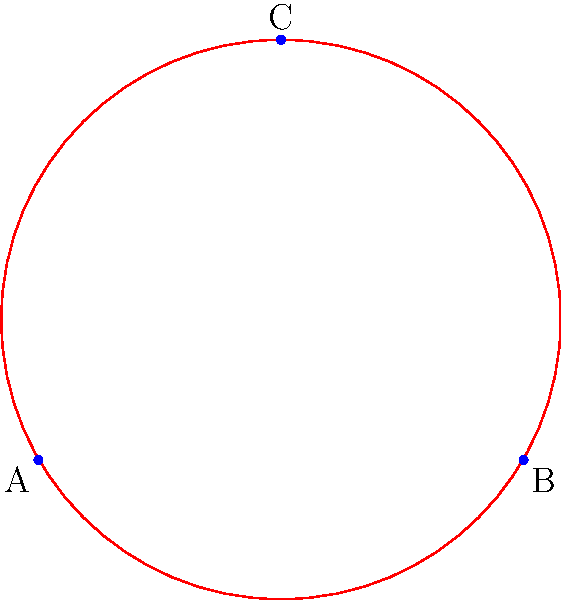A hungry wolf spots three sheep grazing in a field, represented by points A, B, and C. The wolf wants to encircle all three sheep with the smallest possible circular fence. If the distance between sheep A and B is 3 units, what is the radius of the smallest circle that can enclose all three sheep? To find the radius of the smallest circle enclosing three points, we need to follow these steps:

1) First, we recognize that the smallest circle enclosing three points is either:
   a) The circumcircle of the triangle formed by the three points, or
   b) The circle with two of the points as a diameter (if the triangle is obtuse).

2) In this case, we're given that the distance between A and B is 3 units. Let's assume A is at (0,0) and B is at (3,0).

3) To determine the position of C, we can use the properties of an equilateral triangle. The height of an equilateral triangle with side length 3 is $3\sqrt{3}/2 \approx 2.6$ units.

4) So, the coordinates of the three points are:
   A(0,0), B(3,0), C(1.5, 2.6)

5) Now, we can calculate the circumcenter of this triangle. The circumcenter is the intersection of the perpendicular bisectors of the sides.

6) The midpoint of AB is (1.5, 0). The perpendicular bisector of AB passes through this point and is perpendicular to AB.

7) Due to the symmetry of the triangle, we know that the circumcenter will be on the line x = 1.5.

8) The y-coordinate of the circumcenter can be found using the Pythagorean theorem:
   $r^2 = 1.5^2 + y^2 = 2.25 + y^2$
   $r^2 = (3-1.5)^2 + (2.6-y)^2 = 2.25 + (2.6-y)^2$

9) Solving this equation, we find that y ≈ 0.87

10) Therefore, the center of the circle is at (1.5, 0.87)

11) The radius can be calculated as the distance from this point to any of the sheep:
    $r = \sqrt{1.5^2 + 0.87^2} \approx 1.73$ units
Answer: $1.73$ units 